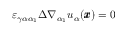<formula> <loc_0><loc_0><loc_500><loc_500>\varepsilon _ { \gamma \alpha \alpha _ { 1 } } \Delta \nabla _ { \alpha _ { 1 } } u _ { \alpha } ( { \pm b x } ) = 0</formula> 